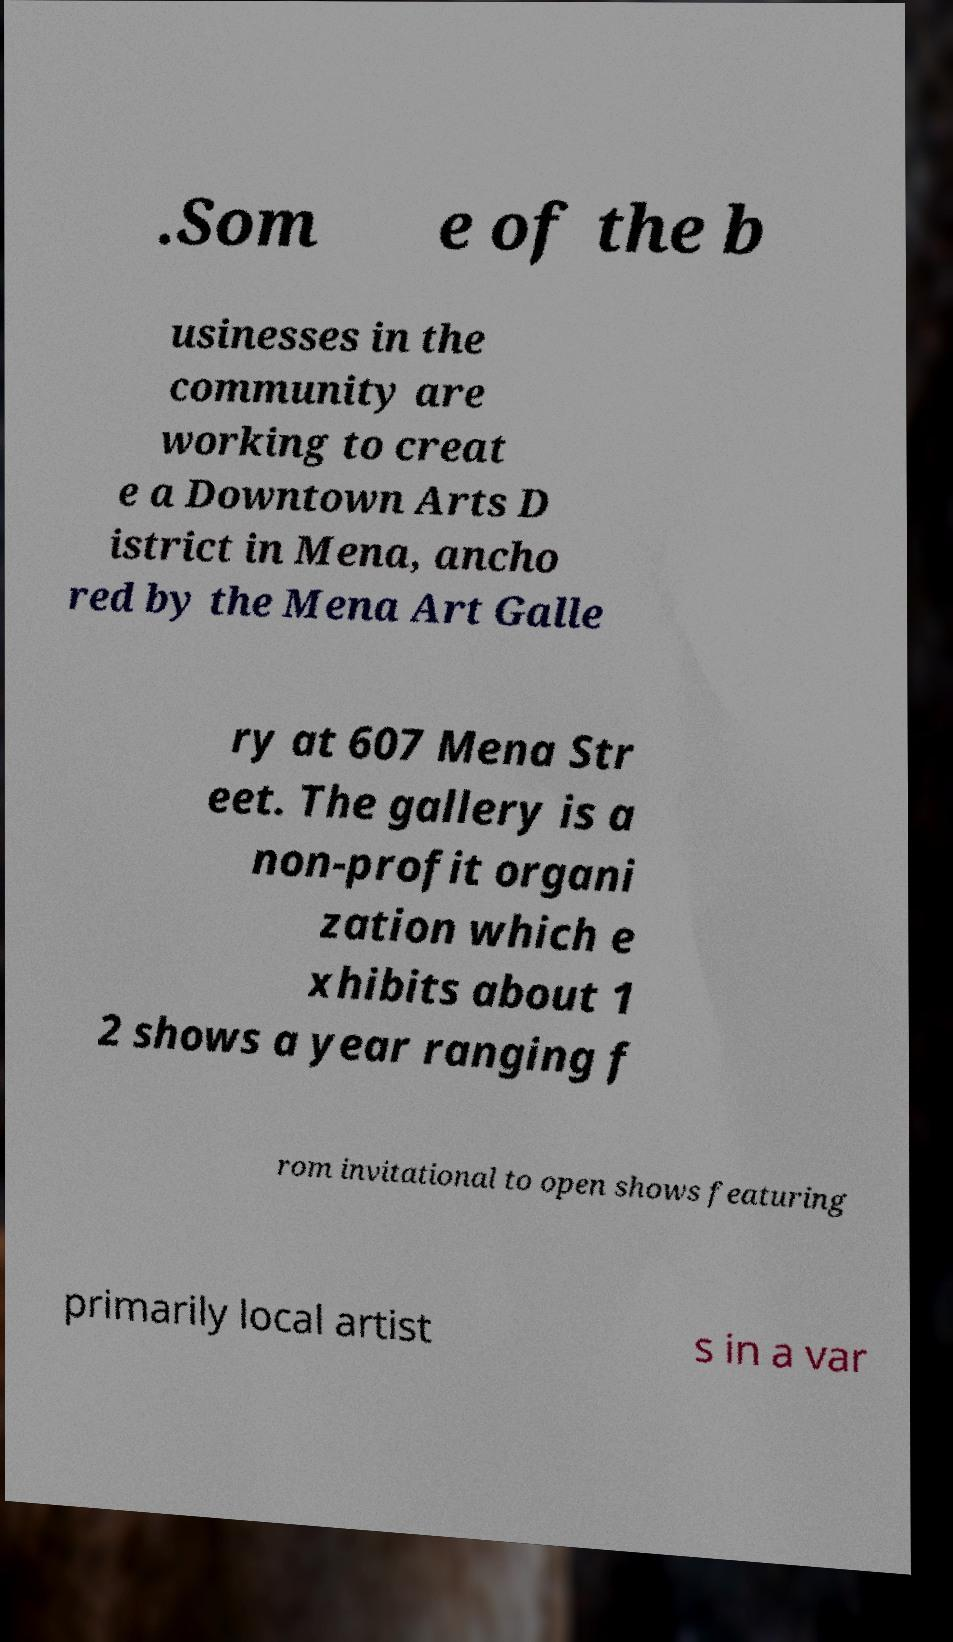Could you extract and type out the text from this image? .Som e of the b usinesses in the community are working to creat e a Downtown Arts D istrict in Mena, ancho red by the Mena Art Galle ry at 607 Mena Str eet. The gallery is a non-profit organi zation which e xhibits about 1 2 shows a year ranging f rom invitational to open shows featuring primarily local artist s in a var 